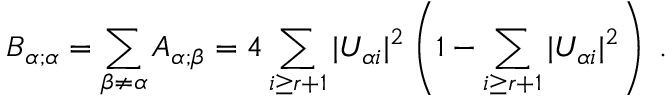<formula> <loc_0><loc_0><loc_500><loc_500>B _ { \alpha ; \alpha } = \sum _ { \beta \neq \alpha } A _ { \alpha ; \beta } = 4 \sum _ { i \geq r + 1 } | U _ { \alpha i } | ^ { 2 } \left ( 1 - \sum _ { i \geq r + 1 } | U _ { \alpha i } | ^ { 2 } \right ) \, .</formula> 